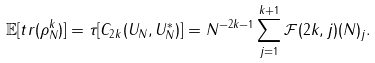<formula> <loc_0><loc_0><loc_500><loc_500>\mathbb { E } [ t r ( \rho _ { N } ^ { k } ) ] = \tau [ C _ { 2 k } ( U _ { N } , U _ { N } ^ { * } ) ] = N ^ { - 2 k - 1 } \sum _ { j = 1 } ^ { k + 1 } \mathcal { F } ( 2 k , j ) ( N ) _ { j } .</formula> 